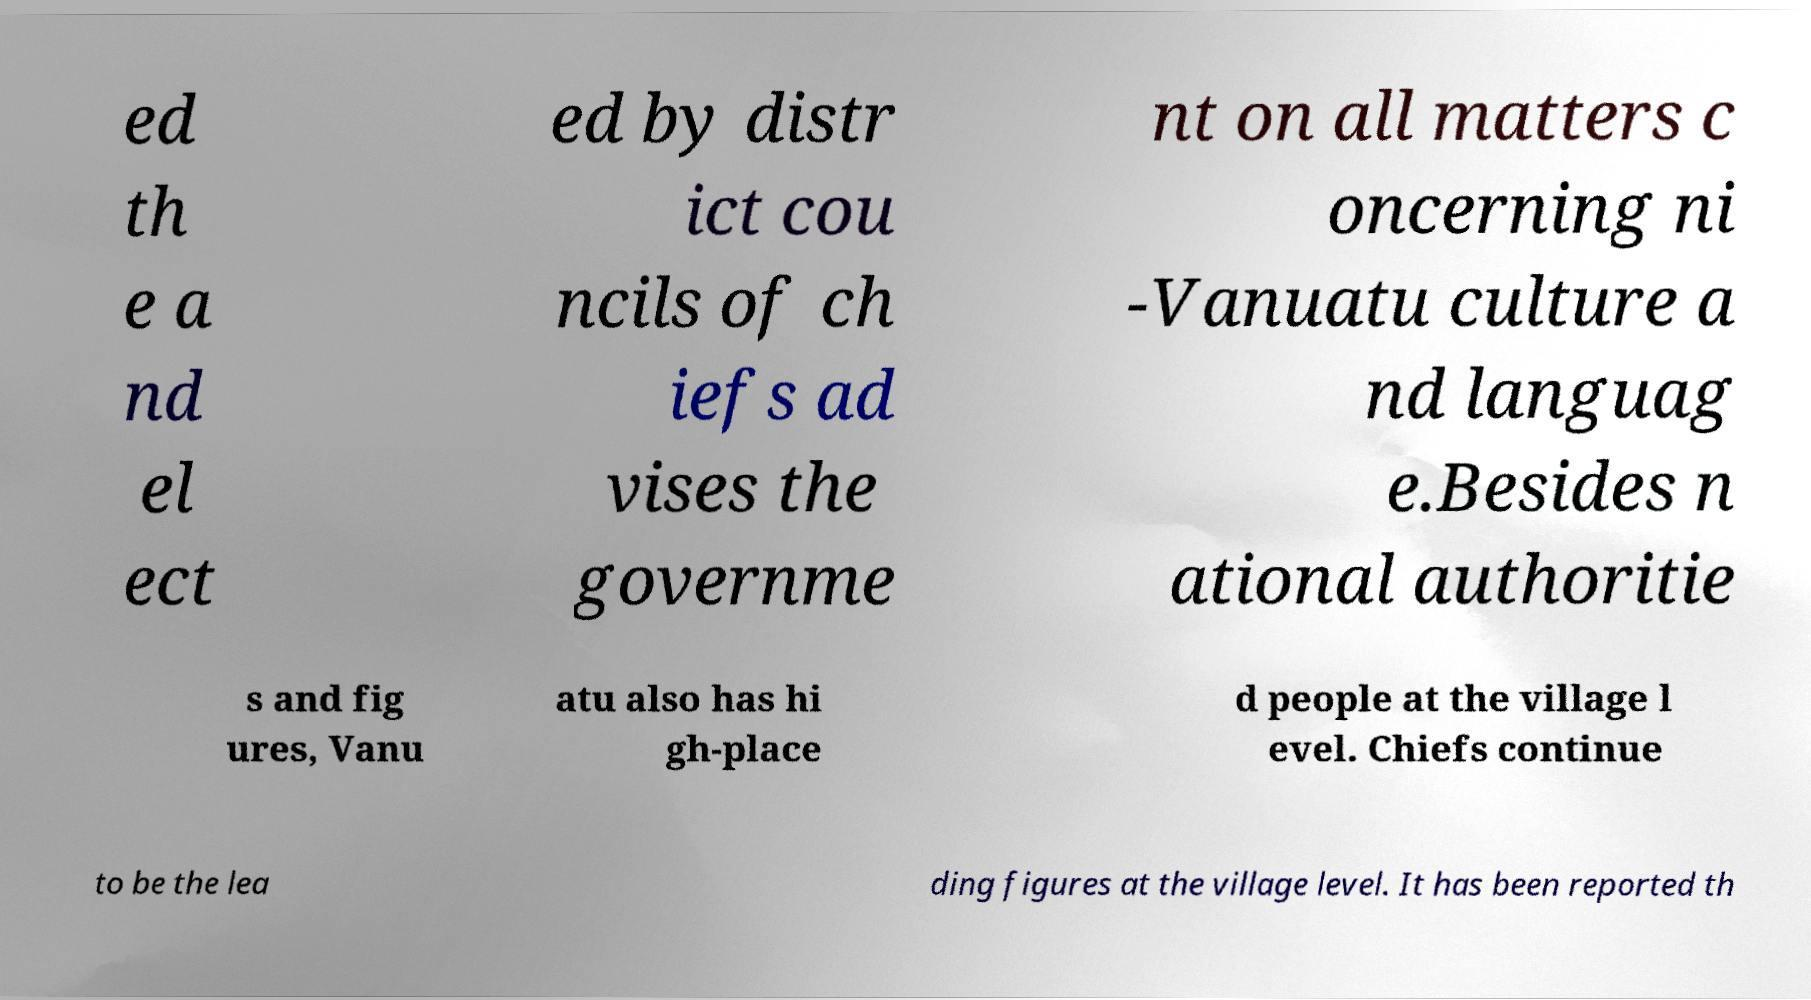What messages or text are displayed in this image? I need them in a readable, typed format. ed th e a nd el ect ed by distr ict cou ncils of ch iefs ad vises the governme nt on all matters c oncerning ni -Vanuatu culture a nd languag e.Besides n ational authoritie s and fig ures, Vanu atu also has hi gh-place d people at the village l evel. Chiefs continue to be the lea ding figures at the village level. It has been reported th 